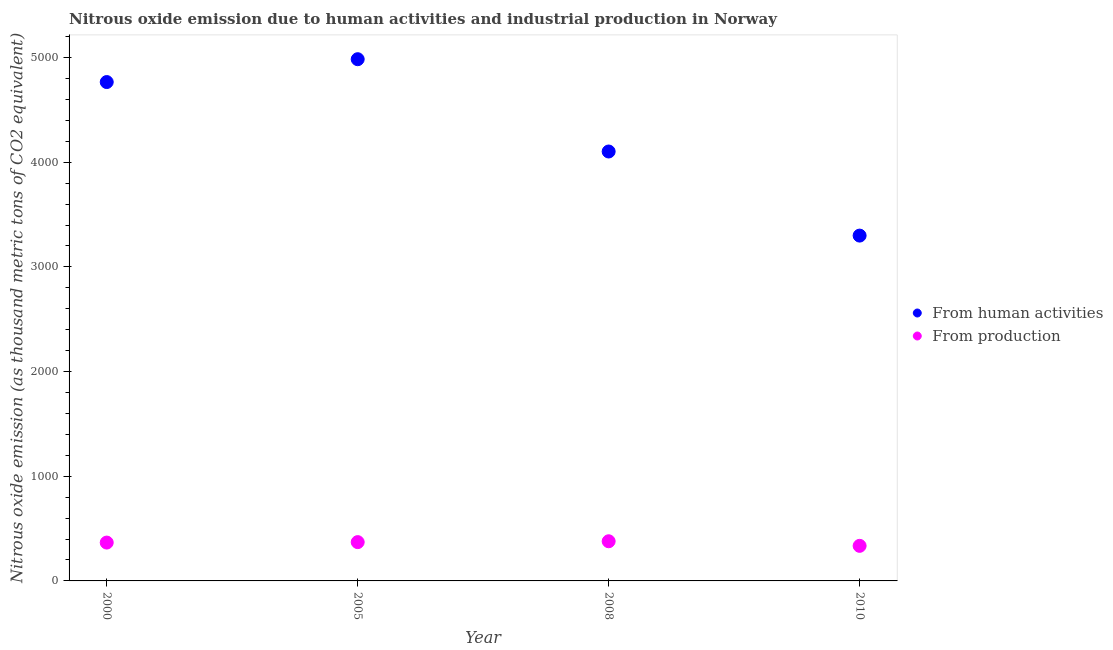How many different coloured dotlines are there?
Provide a short and direct response. 2. Is the number of dotlines equal to the number of legend labels?
Make the answer very short. Yes. What is the amount of emissions from human activities in 2000?
Your answer should be compact. 4766.2. Across all years, what is the maximum amount of emissions generated from industries?
Make the answer very short. 378.9. Across all years, what is the minimum amount of emissions from human activities?
Your answer should be compact. 3299.2. In which year was the amount of emissions generated from industries maximum?
Offer a terse response. 2008. What is the total amount of emissions generated from industries in the graph?
Make the answer very short. 1451.1. What is the difference between the amount of emissions generated from industries in 2000 and that in 2005?
Ensure brevity in your answer.  -4.3. What is the difference between the amount of emissions generated from industries in 2010 and the amount of emissions from human activities in 2000?
Provide a short and direct response. -4431.1. What is the average amount of emissions generated from industries per year?
Offer a terse response. 362.77. In the year 2010, what is the difference between the amount of emissions from human activities and amount of emissions generated from industries?
Offer a terse response. 2964.1. In how many years, is the amount of emissions from human activities greater than 5000 thousand metric tons?
Provide a succinct answer. 0. What is the ratio of the amount of emissions from human activities in 2005 to that in 2010?
Provide a succinct answer. 1.51. What is the difference between the highest and the second highest amount of emissions generated from industries?
Offer a very short reply. 8.2. What is the difference between the highest and the lowest amount of emissions generated from industries?
Provide a succinct answer. 43.8. Is the sum of the amount of emissions generated from industries in 2005 and 2010 greater than the maximum amount of emissions from human activities across all years?
Your answer should be compact. No. Is the amount of emissions from human activities strictly greater than the amount of emissions generated from industries over the years?
Your answer should be compact. Yes. How many years are there in the graph?
Your response must be concise. 4. What is the difference between two consecutive major ticks on the Y-axis?
Your response must be concise. 1000. Are the values on the major ticks of Y-axis written in scientific E-notation?
Offer a very short reply. No. Does the graph contain grids?
Your answer should be very brief. No. How are the legend labels stacked?
Offer a terse response. Vertical. What is the title of the graph?
Offer a very short reply. Nitrous oxide emission due to human activities and industrial production in Norway. Does "Resident" appear as one of the legend labels in the graph?
Your response must be concise. No. What is the label or title of the X-axis?
Offer a terse response. Year. What is the label or title of the Y-axis?
Provide a short and direct response. Nitrous oxide emission (as thousand metric tons of CO2 equivalent). What is the Nitrous oxide emission (as thousand metric tons of CO2 equivalent) of From human activities in 2000?
Keep it short and to the point. 4766.2. What is the Nitrous oxide emission (as thousand metric tons of CO2 equivalent) in From production in 2000?
Offer a terse response. 366.4. What is the Nitrous oxide emission (as thousand metric tons of CO2 equivalent) of From human activities in 2005?
Your answer should be compact. 4984.5. What is the Nitrous oxide emission (as thousand metric tons of CO2 equivalent) of From production in 2005?
Offer a very short reply. 370.7. What is the Nitrous oxide emission (as thousand metric tons of CO2 equivalent) in From human activities in 2008?
Your answer should be compact. 4102.7. What is the Nitrous oxide emission (as thousand metric tons of CO2 equivalent) in From production in 2008?
Your answer should be compact. 378.9. What is the Nitrous oxide emission (as thousand metric tons of CO2 equivalent) in From human activities in 2010?
Offer a terse response. 3299.2. What is the Nitrous oxide emission (as thousand metric tons of CO2 equivalent) of From production in 2010?
Provide a succinct answer. 335.1. Across all years, what is the maximum Nitrous oxide emission (as thousand metric tons of CO2 equivalent) in From human activities?
Your response must be concise. 4984.5. Across all years, what is the maximum Nitrous oxide emission (as thousand metric tons of CO2 equivalent) of From production?
Provide a succinct answer. 378.9. Across all years, what is the minimum Nitrous oxide emission (as thousand metric tons of CO2 equivalent) in From human activities?
Give a very brief answer. 3299.2. Across all years, what is the minimum Nitrous oxide emission (as thousand metric tons of CO2 equivalent) of From production?
Make the answer very short. 335.1. What is the total Nitrous oxide emission (as thousand metric tons of CO2 equivalent) in From human activities in the graph?
Your answer should be compact. 1.72e+04. What is the total Nitrous oxide emission (as thousand metric tons of CO2 equivalent) in From production in the graph?
Provide a short and direct response. 1451.1. What is the difference between the Nitrous oxide emission (as thousand metric tons of CO2 equivalent) in From human activities in 2000 and that in 2005?
Make the answer very short. -218.3. What is the difference between the Nitrous oxide emission (as thousand metric tons of CO2 equivalent) of From production in 2000 and that in 2005?
Make the answer very short. -4.3. What is the difference between the Nitrous oxide emission (as thousand metric tons of CO2 equivalent) of From human activities in 2000 and that in 2008?
Your answer should be very brief. 663.5. What is the difference between the Nitrous oxide emission (as thousand metric tons of CO2 equivalent) of From production in 2000 and that in 2008?
Keep it short and to the point. -12.5. What is the difference between the Nitrous oxide emission (as thousand metric tons of CO2 equivalent) in From human activities in 2000 and that in 2010?
Keep it short and to the point. 1467. What is the difference between the Nitrous oxide emission (as thousand metric tons of CO2 equivalent) in From production in 2000 and that in 2010?
Provide a short and direct response. 31.3. What is the difference between the Nitrous oxide emission (as thousand metric tons of CO2 equivalent) of From human activities in 2005 and that in 2008?
Ensure brevity in your answer.  881.8. What is the difference between the Nitrous oxide emission (as thousand metric tons of CO2 equivalent) in From production in 2005 and that in 2008?
Offer a terse response. -8.2. What is the difference between the Nitrous oxide emission (as thousand metric tons of CO2 equivalent) of From human activities in 2005 and that in 2010?
Your answer should be compact. 1685.3. What is the difference between the Nitrous oxide emission (as thousand metric tons of CO2 equivalent) of From production in 2005 and that in 2010?
Offer a terse response. 35.6. What is the difference between the Nitrous oxide emission (as thousand metric tons of CO2 equivalent) in From human activities in 2008 and that in 2010?
Offer a very short reply. 803.5. What is the difference between the Nitrous oxide emission (as thousand metric tons of CO2 equivalent) in From production in 2008 and that in 2010?
Offer a very short reply. 43.8. What is the difference between the Nitrous oxide emission (as thousand metric tons of CO2 equivalent) of From human activities in 2000 and the Nitrous oxide emission (as thousand metric tons of CO2 equivalent) of From production in 2005?
Your answer should be very brief. 4395.5. What is the difference between the Nitrous oxide emission (as thousand metric tons of CO2 equivalent) of From human activities in 2000 and the Nitrous oxide emission (as thousand metric tons of CO2 equivalent) of From production in 2008?
Your answer should be compact. 4387.3. What is the difference between the Nitrous oxide emission (as thousand metric tons of CO2 equivalent) in From human activities in 2000 and the Nitrous oxide emission (as thousand metric tons of CO2 equivalent) in From production in 2010?
Make the answer very short. 4431.1. What is the difference between the Nitrous oxide emission (as thousand metric tons of CO2 equivalent) of From human activities in 2005 and the Nitrous oxide emission (as thousand metric tons of CO2 equivalent) of From production in 2008?
Provide a short and direct response. 4605.6. What is the difference between the Nitrous oxide emission (as thousand metric tons of CO2 equivalent) in From human activities in 2005 and the Nitrous oxide emission (as thousand metric tons of CO2 equivalent) in From production in 2010?
Your answer should be very brief. 4649.4. What is the difference between the Nitrous oxide emission (as thousand metric tons of CO2 equivalent) of From human activities in 2008 and the Nitrous oxide emission (as thousand metric tons of CO2 equivalent) of From production in 2010?
Your response must be concise. 3767.6. What is the average Nitrous oxide emission (as thousand metric tons of CO2 equivalent) in From human activities per year?
Ensure brevity in your answer.  4288.15. What is the average Nitrous oxide emission (as thousand metric tons of CO2 equivalent) in From production per year?
Keep it short and to the point. 362.77. In the year 2000, what is the difference between the Nitrous oxide emission (as thousand metric tons of CO2 equivalent) of From human activities and Nitrous oxide emission (as thousand metric tons of CO2 equivalent) of From production?
Offer a very short reply. 4399.8. In the year 2005, what is the difference between the Nitrous oxide emission (as thousand metric tons of CO2 equivalent) of From human activities and Nitrous oxide emission (as thousand metric tons of CO2 equivalent) of From production?
Your response must be concise. 4613.8. In the year 2008, what is the difference between the Nitrous oxide emission (as thousand metric tons of CO2 equivalent) of From human activities and Nitrous oxide emission (as thousand metric tons of CO2 equivalent) of From production?
Ensure brevity in your answer.  3723.8. In the year 2010, what is the difference between the Nitrous oxide emission (as thousand metric tons of CO2 equivalent) of From human activities and Nitrous oxide emission (as thousand metric tons of CO2 equivalent) of From production?
Offer a very short reply. 2964.1. What is the ratio of the Nitrous oxide emission (as thousand metric tons of CO2 equivalent) in From human activities in 2000 to that in 2005?
Keep it short and to the point. 0.96. What is the ratio of the Nitrous oxide emission (as thousand metric tons of CO2 equivalent) of From production in 2000 to that in 2005?
Ensure brevity in your answer.  0.99. What is the ratio of the Nitrous oxide emission (as thousand metric tons of CO2 equivalent) in From human activities in 2000 to that in 2008?
Offer a very short reply. 1.16. What is the ratio of the Nitrous oxide emission (as thousand metric tons of CO2 equivalent) in From human activities in 2000 to that in 2010?
Ensure brevity in your answer.  1.44. What is the ratio of the Nitrous oxide emission (as thousand metric tons of CO2 equivalent) of From production in 2000 to that in 2010?
Offer a very short reply. 1.09. What is the ratio of the Nitrous oxide emission (as thousand metric tons of CO2 equivalent) of From human activities in 2005 to that in 2008?
Ensure brevity in your answer.  1.21. What is the ratio of the Nitrous oxide emission (as thousand metric tons of CO2 equivalent) in From production in 2005 to that in 2008?
Your response must be concise. 0.98. What is the ratio of the Nitrous oxide emission (as thousand metric tons of CO2 equivalent) of From human activities in 2005 to that in 2010?
Give a very brief answer. 1.51. What is the ratio of the Nitrous oxide emission (as thousand metric tons of CO2 equivalent) of From production in 2005 to that in 2010?
Provide a short and direct response. 1.11. What is the ratio of the Nitrous oxide emission (as thousand metric tons of CO2 equivalent) in From human activities in 2008 to that in 2010?
Make the answer very short. 1.24. What is the ratio of the Nitrous oxide emission (as thousand metric tons of CO2 equivalent) in From production in 2008 to that in 2010?
Offer a very short reply. 1.13. What is the difference between the highest and the second highest Nitrous oxide emission (as thousand metric tons of CO2 equivalent) of From human activities?
Your answer should be compact. 218.3. What is the difference between the highest and the second highest Nitrous oxide emission (as thousand metric tons of CO2 equivalent) in From production?
Ensure brevity in your answer.  8.2. What is the difference between the highest and the lowest Nitrous oxide emission (as thousand metric tons of CO2 equivalent) in From human activities?
Your response must be concise. 1685.3. What is the difference between the highest and the lowest Nitrous oxide emission (as thousand metric tons of CO2 equivalent) in From production?
Provide a succinct answer. 43.8. 